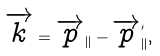Convert formula to latex. <formula><loc_0><loc_0><loc_500><loc_500>\overrightarrow { k } = \overrightarrow { p } _ { \| } - \overrightarrow { p } _ { \| } ^ { ^ { \prime } } ,</formula> 